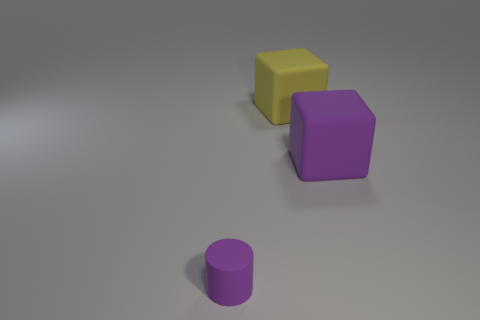Add 3 tiny matte cylinders. How many objects exist? 6 Subtract all cyan cylinders. How many green cubes are left? 0 Subtract 0 red blocks. How many objects are left? 3 Subtract all cubes. How many objects are left? 1 Subtract 1 cylinders. How many cylinders are left? 0 Subtract all green cylinders. Subtract all yellow cubes. How many cylinders are left? 1 Subtract all yellow rubber things. Subtract all large red matte cubes. How many objects are left? 2 Add 2 large blocks. How many large blocks are left? 4 Add 1 yellow blocks. How many yellow blocks exist? 2 